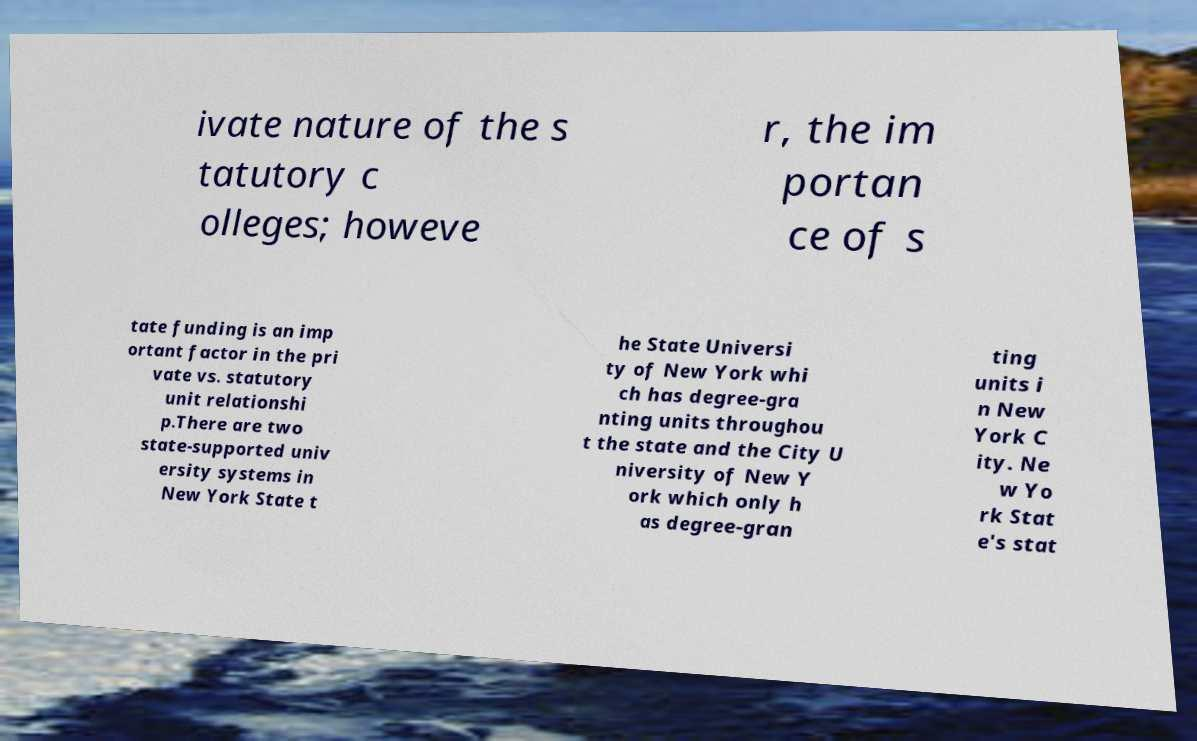Please identify and transcribe the text found in this image. ivate nature of the s tatutory c olleges; howeve r, the im portan ce of s tate funding is an imp ortant factor in the pri vate vs. statutory unit relationshi p.There are two state-supported univ ersity systems in New York State t he State Universi ty of New York whi ch has degree-gra nting units throughou t the state and the City U niversity of New Y ork which only h as degree-gran ting units i n New York C ity. Ne w Yo rk Stat e's stat 